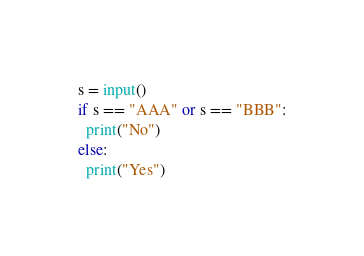Convert code to text. <code><loc_0><loc_0><loc_500><loc_500><_Python_>s = input()
if s == "AAA" or s == "BBB":
  print("No")
else:
  print("Yes")</code> 